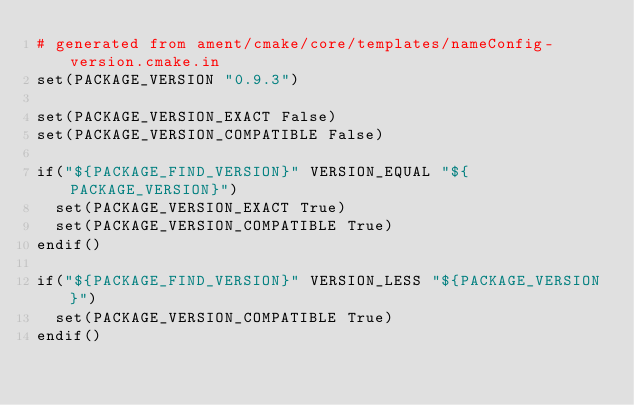<code> <loc_0><loc_0><loc_500><loc_500><_CMake_># generated from ament/cmake/core/templates/nameConfig-version.cmake.in
set(PACKAGE_VERSION "0.9.3")

set(PACKAGE_VERSION_EXACT False)
set(PACKAGE_VERSION_COMPATIBLE False)

if("${PACKAGE_FIND_VERSION}" VERSION_EQUAL "${PACKAGE_VERSION}")
  set(PACKAGE_VERSION_EXACT True)
  set(PACKAGE_VERSION_COMPATIBLE True)
endif()

if("${PACKAGE_FIND_VERSION}" VERSION_LESS "${PACKAGE_VERSION}")
  set(PACKAGE_VERSION_COMPATIBLE True)
endif()
</code> 